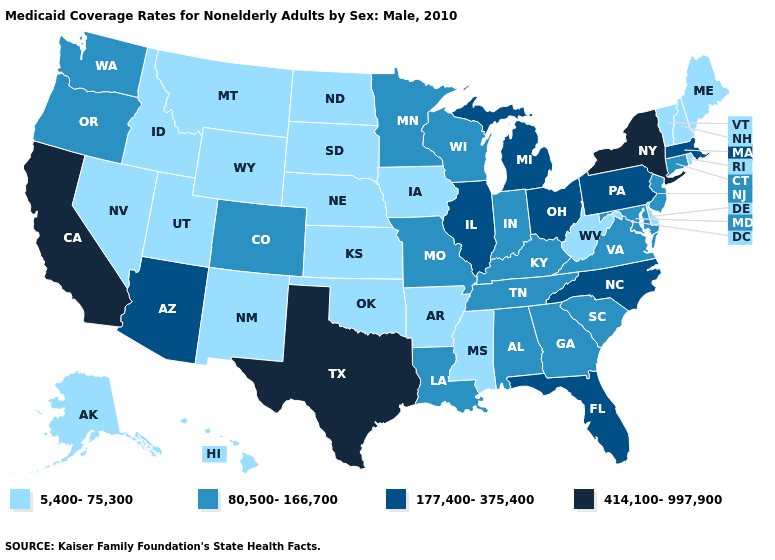What is the value of Massachusetts?
Keep it brief. 177,400-375,400. What is the highest value in the USA?
Be succinct. 414,100-997,900. Among the states that border Indiana , does Kentucky have the highest value?
Keep it brief. No. Name the states that have a value in the range 414,100-997,900?
Concise answer only. California, New York, Texas. Does New Jersey have a lower value than South Carolina?
Give a very brief answer. No. Which states have the lowest value in the USA?
Write a very short answer. Alaska, Arkansas, Delaware, Hawaii, Idaho, Iowa, Kansas, Maine, Mississippi, Montana, Nebraska, Nevada, New Hampshire, New Mexico, North Dakota, Oklahoma, Rhode Island, South Dakota, Utah, Vermont, West Virginia, Wyoming. Does the first symbol in the legend represent the smallest category?
Short answer required. Yes. Does Texas have the highest value in the USA?
Be succinct. Yes. Which states have the lowest value in the USA?
Concise answer only. Alaska, Arkansas, Delaware, Hawaii, Idaho, Iowa, Kansas, Maine, Mississippi, Montana, Nebraska, Nevada, New Hampshire, New Mexico, North Dakota, Oklahoma, Rhode Island, South Dakota, Utah, Vermont, West Virginia, Wyoming. What is the value of Nebraska?
Be succinct. 5,400-75,300. Name the states that have a value in the range 80,500-166,700?
Concise answer only. Alabama, Colorado, Connecticut, Georgia, Indiana, Kentucky, Louisiana, Maryland, Minnesota, Missouri, New Jersey, Oregon, South Carolina, Tennessee, Virginia, Washington, Wisconsin. Does Iowa have the lowest value in the USA?
Keep it brief. Yes. Does Indiana have the lowest value in the MidWest?
Quick response, please. No. What is the highest value in states that border North Dakota?
Answer briefly. 80,500-166,700. What is the highest value in states that border Pennsylvania?
Write a very short answer. 414,100-997,900. 